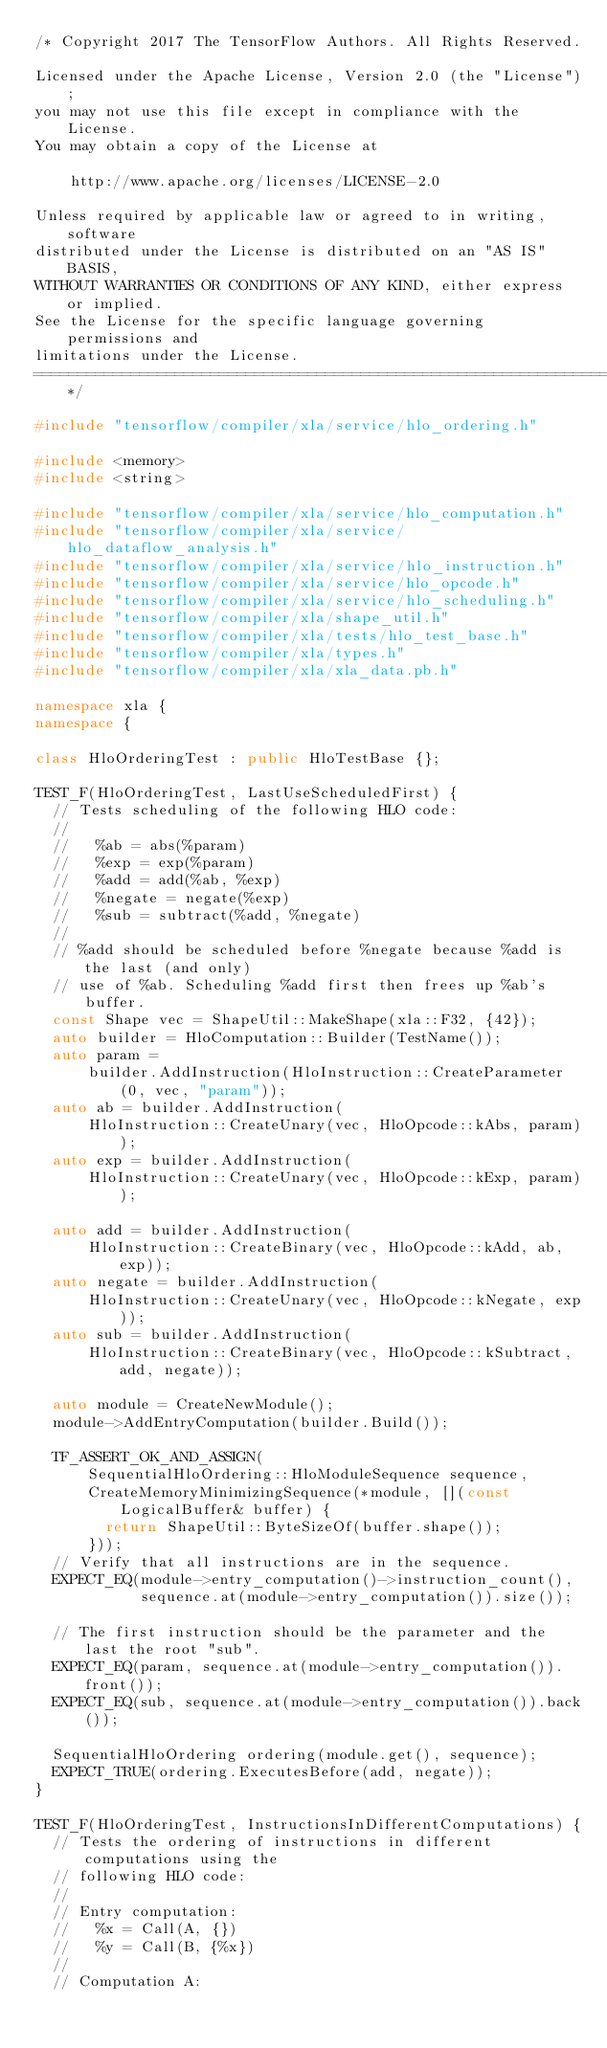<code> <loc_0><loc_0><loc_500><loc_500><_C++_>/* Copyright 2017 The TensorFlow Authors. All Rights Reserved.

Licensed under the Apache License, Version 2.0 (the "License");
you may not use this file except in compliance with the License.
You may obtain a copy of the License at

    http://www.apache.org/licenses/LICENSE-2.0

Unless required by applicable law or agreed to in writing, software
distributed under the License is distributed on an "AS IS" BASIS,
WITHOUT WARRANTIES OR CONDITIONS OF ANY KIND, either express or implied.
See the License for the specific language governing permissions and
limitations under the License.
==============================================================================*/

#include "tensorflow/compiler/xla/service/hlo_ordering.h"

#include <memory>
#include <string>

#include "tensorflow/compiler/xla/service/hlo_computation.h"
#include "tensorflow/compiler/xla/service/hlo_dataflow_analysis.h"
#include "tensorflow/compiler/xla/service/hlo_instruction.h"
#include "tensorflow/compiler/xla/service/hlo_opcode.h"
#include "tensorflow/compiler/xla/service/hlo_scheduling.h"
#include "tensorflow/compiler/xla/shape_util.h"
#include "tensorflow/compiler/xla/tests/hlo_test_base.h"
#include "tensorflow/compiler/xla/types.h"
#include "tensorflow/compiler/xla/xla_data.pb.h"

namespace xla {
namespace {

class HloOrderingTest : public HloTestBase {};

TEST_F(HloOrderingTest, LastUseScheduledFirst) {
  // Tests scheduling of the following HLO code:
  //
  //   %ab = abs(%param)
  //   %exp = exp(%param)
  //   %add = add(%ab, %exp)
  //   %negate = negate(%exp)
  //   %sub = subtract(%add, %negate)
  //
  // %add should be scheduled before %negate because %add is the last (and only)
  // use of %ab. Scheduling %add first then frees up %ab's buffer.
  const Shape vec = ShapeUtil::MakeShape(xla::F32, {42});
  auto builder = HloComputation::Builder(TestName());
  auto param =
      builder.AddInstruction(HloInstruction::CreateParameter(0, vec, "param"));
  auto ab = builder.AddInstruction(
      HloInstruction::CreateUnary(vec, HloOpcode::kAbs, param));
  auto exp = builder.AddInstruction(
      HloInstruction::CreateUnary(vec, HloOpcode::kExp, param));

  auto add = builder.AddInstruction(
      HloInstruction::CreateBinary(vec, HloOpcode::kAdd, ab, exp));
  auto negate = builder.AddInstruction(
      HloInstruction::CreateUnary(vec, HloOpcode::kNegate, exp));
  auto sub = builder.AddInstruction(
      HloInstruction::CreateBinary(vec, HloOpcode::kSubtract, add, negate));

  auto module = CreateNewModule();
  module->AddEntryComputation(builder.Build());

  TF_ASSERT_OK_AND_ASSIGN(
      SequentialHloOrdering::HloModuleSequence sequence,
      CreateMemoryMinimizingSequence(*module, [](const LogicalBuffer& buffer) {
        return ShapeUtil::ByteSizeOf(buffer.shape());
      }));
  // Verify that all instructions are in the sequence.
  EXPECT_EQ(module->entry_computation()->instruction_count(),
            sequence.at(module->entry_computation()).size());

  // The first instruction should be the parameter and the last the root "sub".
  EXPECT_EQ(param, sequence.at(module->entry_computation()).front());
  EXPECT_EQ(sub, sequence.at(module->entry_computation()).back());

  SequentialHloOrdering ordering(module.get(), sequence);
  EXPECT_TRUE(ordering.ExecutesBefore(add, negate));
}

TEST_F(HloOrderingTest, InstructionsInDifferentComputations) {
  // Tests the ordering of instructions in different computations using the
  // following HLO code:
  //
  // Entry computation:
  //   %x = Call(A, {})
  //   %y = Call(B, {%x})
  //
  // Computation A:</code> 